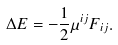Convert formula to latex. <formula><loc_0><loc_0><loc_500><loc_500>\Delta E = - \frac { 1 } { 2 } \mu ^ { i j } F _ { i j } .</formula> 